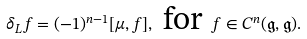Convert formula to latex. <formula><loc_0><loc_0><loc_500><loc_500>\delta _ { L } f = ( - 1 ) ^ { n - 1 } [ \mu , f ] , \text { for } f \in C ^ { n } ( \mathfrak { g } , \mathfrak { g } ) .</formula> 